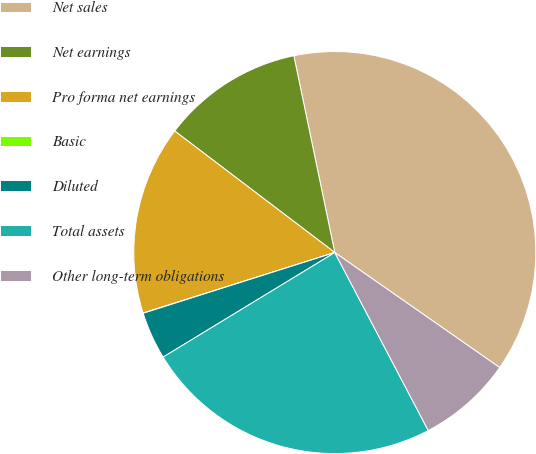Convert chart to OTSL. <chart><loc_0><loc_0><loc_500><loc_500><pie_chart><fcel>Net sales<fcel>Net earnings<fcel>Pro forma net earnings<fcel>Basic<fcel>Diluted<fcel>Total assets<fcel>Other long-term obligations<nl><fcel>37.96%<fcel>11.4%<fcel>15.2%<fcel>0.02%<fcel>3.82%<fcel>23.99%<fcel>7.61%<nl></chart> 